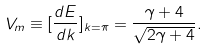Convert formula to latex. <formula><loc_0><loc_0><loc_500><loc_500>V _ { m } \equiv [ \frac { d E } { d k } ] _ { k = \pi } = \frac { \gamma + 4 } { \sqrt { 2 \gamma + 4 } } .</formula> 